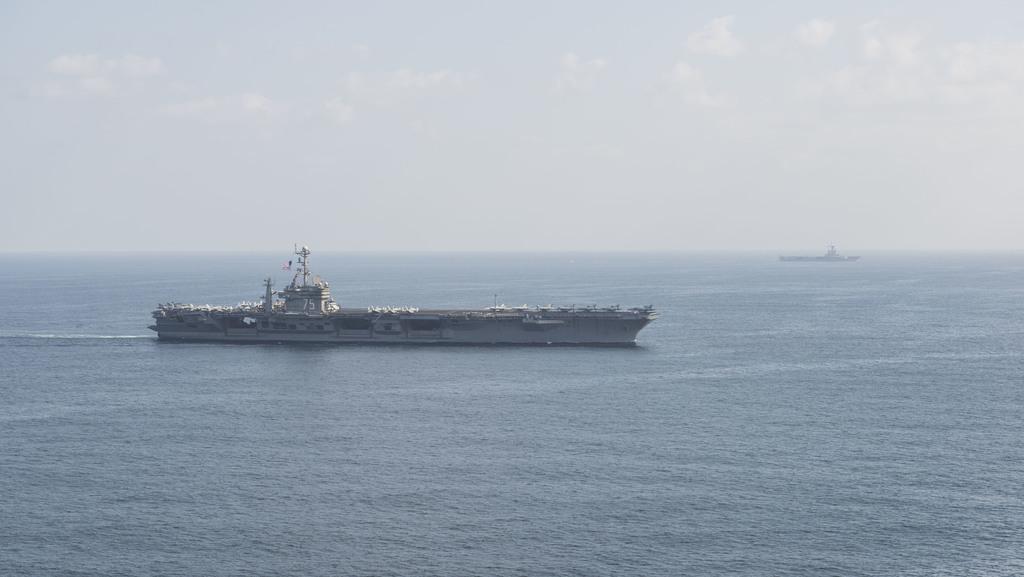In one or two sentences, can you explain what this image depicts? In this image we can see a two ships in a large water body. On the backside we can see the sky which looks cloudy. 